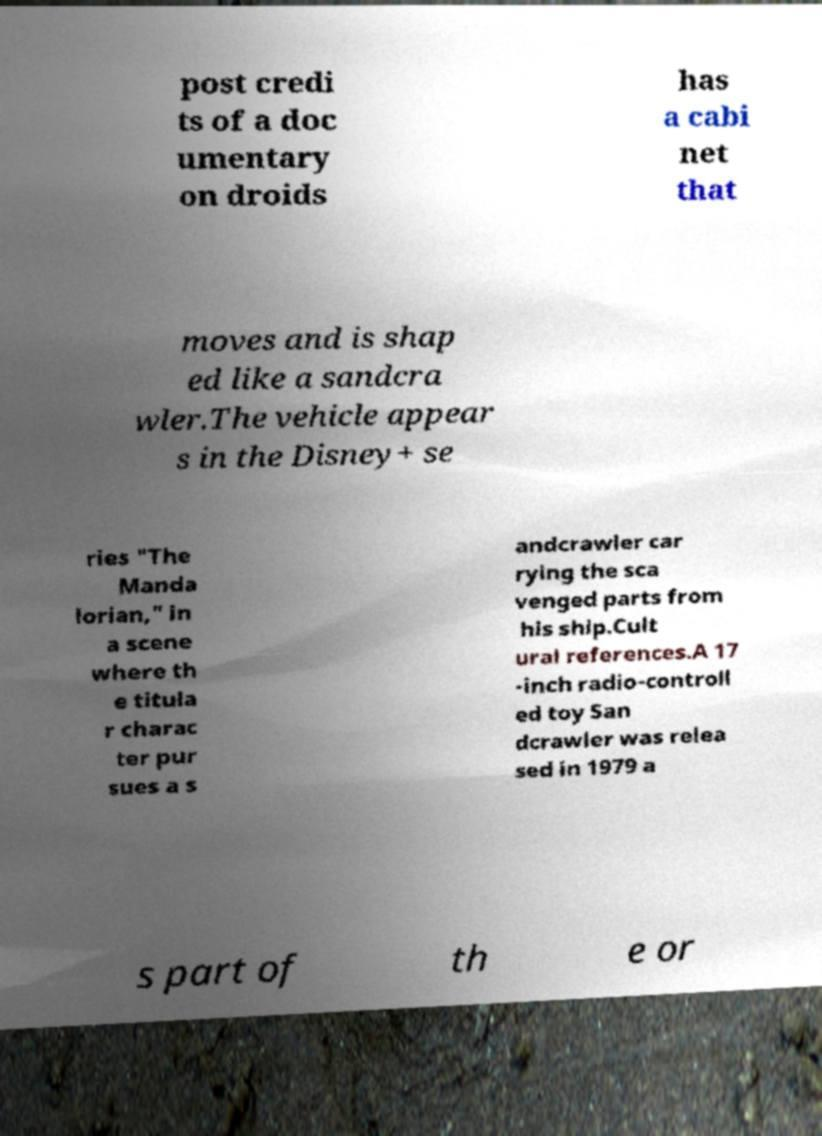Could you extract and type out the text from this image? post credi ts of a doc umentary on droids has a cabi net that moves and is shap ed like a sandcra wler.The vehicle appear s in the Disney+ se ries "The Manda lorian," in a scene where th e titula r charac ter pur sues a s andcrawler car rying the sca venged parts from his ship.Cult ural references.A 17 -inch radio-controll ed toy San dcrawler was relea sed in 1979 a s part of th e or 